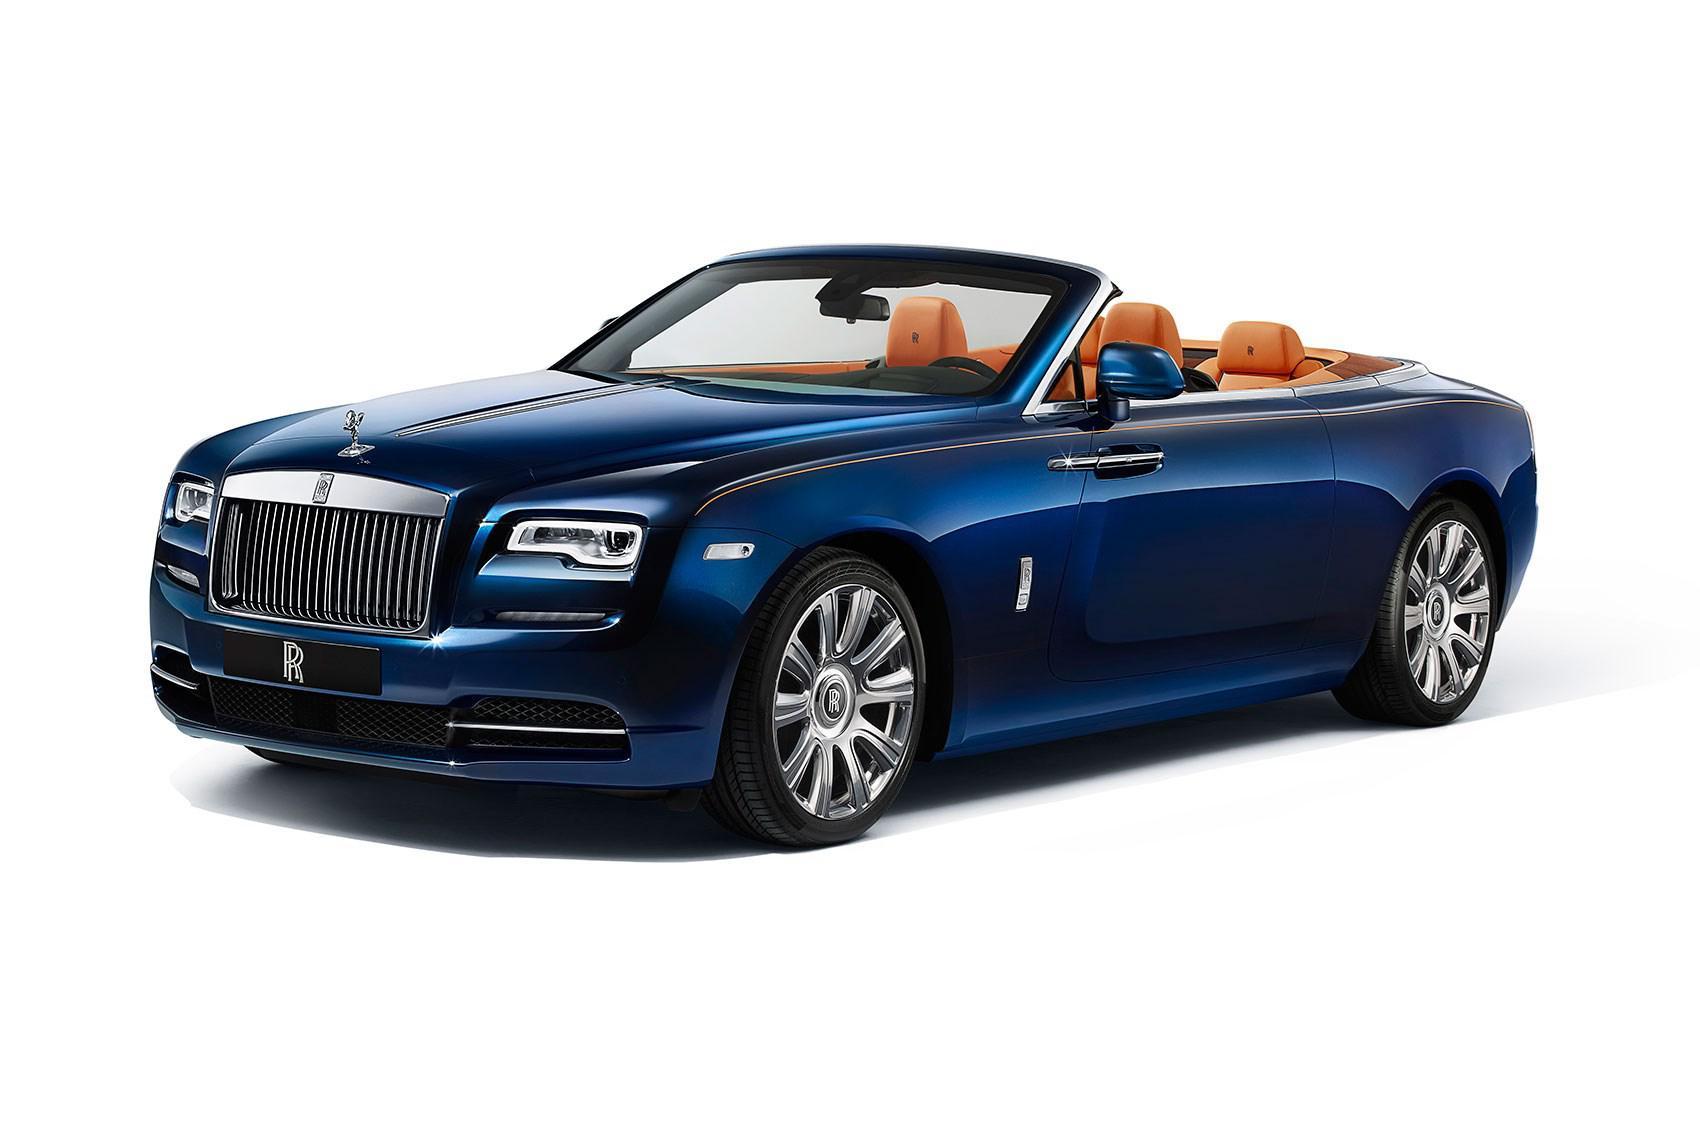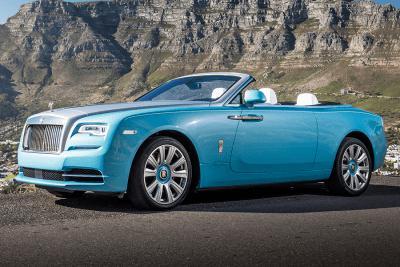The first image is the image on the left, the second image is the image on the right. For the images displayed, is the sentence "There is a car with brown seats." factually correct? Answer yes or no. Yes. The first image is the image on the left, the second image is the image on the right. For the images shown, is this caption "In each image there is a blue convertible that is facing the left." true? Answer yes or no. Yes. 